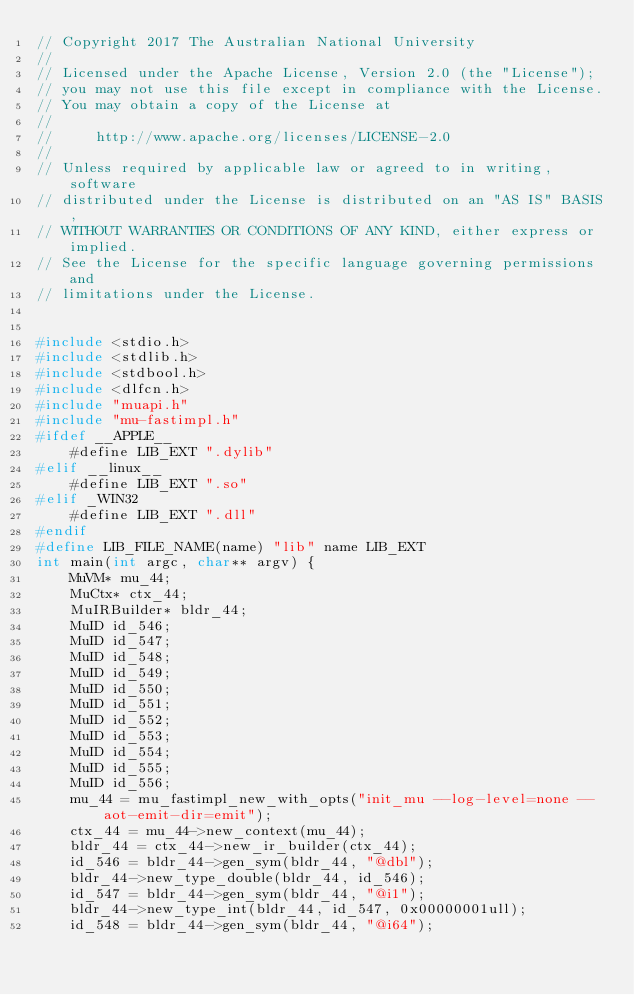Convert code to text. <code><loc_0><loc_0><loc_500><loc_500><_C_>// Copyright 2017 The Australian National University
// 
// Licensed under the Apache License, Version 2.0 (the "License");
// you may not use this file except in compliance with the License.
// You may obtain a copy of the License at
// 
//     http://www.apache.org/licenses/LICENSE-2.0
// 
// Unless required by applicable law or agreed to in writing, software
// distributed under the License is distributed on an "AS IS" BASIS,
// WITHOUT WARRANTIES OR CONDITIONS OF ANY KIND, either express or implied.
// See the License for the specific language governing permissions and
// limitations under the License.


#include <stdio.h>
#include <stdlib.h>
#include <stdbool.h>
#include <dlfcn.h>
#include "muapi.h"
#include "mu-fastimpl.h"
#ifdef __APPLE__
    #define LIB_EXT ".dylib"
#elif __linux__
    #define LIB_EXT ".so"
#elif _WIN32
    #define LIB_EXT ".dll"
#endif
#define LIB_FILE_NAME(name) "lib" name LIB_EXT
int main(int argc, char** argv) {
    MuVM* mu_44;
    MuCtx* ctx_44;
    MuIRBuilder* bldr_44;
    MuID id_546;
    MuID id_547;
    MuID id_548;
    MuID id_549;
    MuID id_550;
    MuID id_551;
    MuID id_552;
    MuID id_553;
    MuID id_554;
    MuID id_555;
    MuID id_556;
    mu_44 = mu_fastimpl_new_with_opts("init_mu --log-level=none --aot-emit-dir=emit");
    ctx_44 = mu_44->new_context(mu_44);
    bldr_44 = ctx_44->new_ir_builder(ctx_44);
    id_546 = bldr_44->gen_sym(bldr_44, "@dbl");
    bldr_44->new_type_double(bldr_44, id_546);
    id_547 = bldr_44->gen_sym(bldr_44, "@i1");
    bldr_44->new_type_int(bldr_44, id_547, 0x00000001ull);
    id_548 = bldr_44->gen_sym(bldr_44, "@i64");</code> 